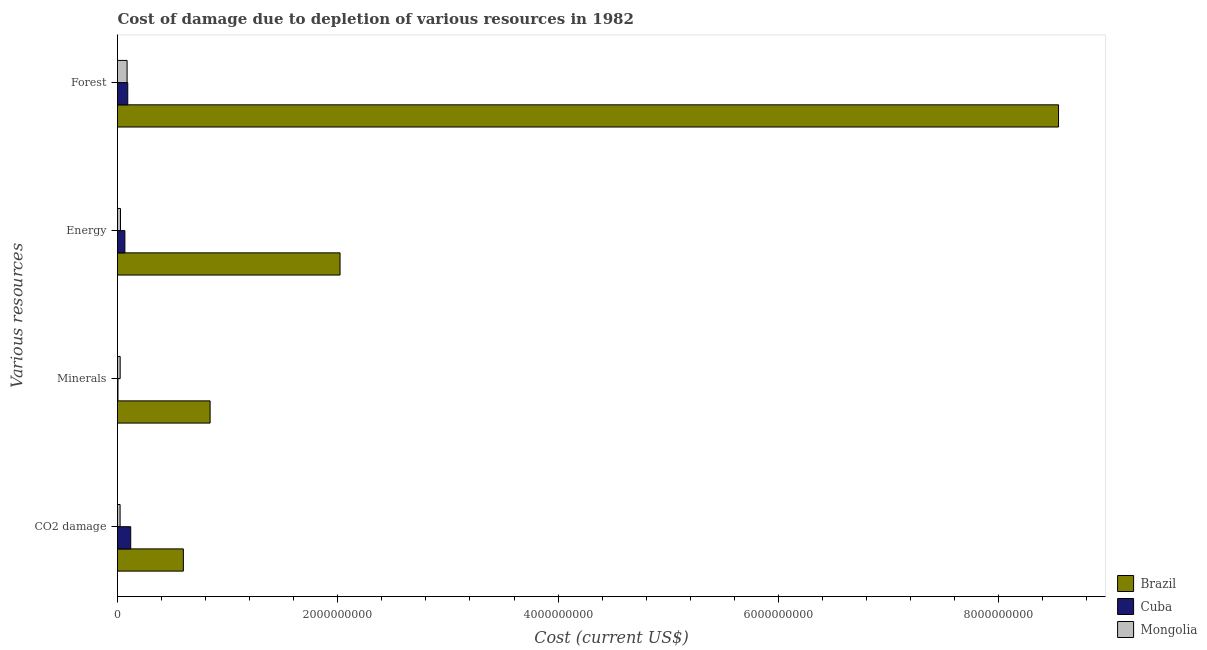How many bars are there on the 1st tick from the top?
Provide a short and direct response. 3. What is the label of the 3rd group of bars from the top?
Offer a very short reply. Minerals. What is the cost of damage due to depletion of energy in Cuba?
Provide a succinct answer. 6.70e+07. Across all countries, what is the maximum cost of damage due to depletion of coal?
Ensure brevity in your answer.  5.98e+08. Across all countries, what is the minimum cost of damage due to depletion of energy?
Your response must be concise. 2.71e+07. In which country was the cost of damage due to depletion of coal maximum?
Provide a short and direct response. Brazil. In which country was the cost of damage due to depletion of energy minimum?
Keep it short and to the point. Mongolia. What is the total cost of damage due to depletion of coal in the graph?
Keep it short and to the point. 7.41e+08. What is the difference between the cost of damage due to depletion of energy in Mongolia and that in Cuba?
Make the answer very short. -3.99e+07. What is the difference between the cost of damage due to depletion of coal in Mongolia and the cost of damage due to depletion of forests in Cuba?
Your response must be concise. -6.97e+07. What is the average cost of damage due to depletion of minerals per country?
Keep it short and to the point. 2.90e+08. What is the difference between the cost of damage due to depletion of minerals and cost of damage due to depletion of coal in Mongolia?
Your answer should be very brief. 7.37e+05. In how many countries, is the cost of damage due to depletion of forests greater than 8400000000 US$?
Ensure brevity in your answer.  1. What is the ratio of the cost of damage due to depletion of minerals in Mongolia to that in Brazil?
Your answer should be compact. 0.03. Is the cost of damage due to depletion of coal in Cuba less than that in Brazil?
Ensure brevity in your answer.  Yes. Is the difference between the cost of damage due to depletion of energy in Mongolia and Cuba greater than the difference between the cost of damage due to depletion of minerals in Mongolia and Cuba?
Ensure brevity in your answer.  No. What is the difference between the highest and the second highest cost of damage due to depletion of forests?
Your response must be concise. 8.45e+09. What is the difference between the highest and the lowest cost of damage due to depletion of energy?
Your answer should be very brief. 1.99e+09. Is the sum of the cost of damage due to depletion of coal in Mongolia and Brazil greater than the maximum cost of damage due to depletion of energy across all countries?
Your response must be concise. No. Is it the case that in every country, the sum of the cost of damage due to depletion of coal and cost of damage due to depletion of minerals is greater than the sum of cost of damage due to depletion of energy and cost of damage due to depletion of forests?
Keep it short and to the point. Yes. What does the 2nd bar from the top in CO2 damage represents?
Ensure brevity in your answer.  Cuba. Is it the case that in every country, the sum of the cost of damage due to depletion of coal and cost of damage due to depletion of minerals is greater than the cost of damage due to depletion of energy?
Your answer should be very brief. No. How many bars are there?
Ensure brevity in your answer.  12. How many countries are there in the graph?
Your answer should be compact. 3. What is the difference between two consecutive major ticks on the X-axis?
Make the answer very short. 2.00e+09. How are the legend labels stacked?
Provide a short and direct response. Vertical. What is the title of the graph?
Your answer should be compact. Cost of damage due to depletion of various resources in 1982 . Does "Belgium" appear as one of the legend labels in the graph?
Make the answer very short. No. What is the label or title of the X-axis?
Make the answer very short. Cost (current US$). What is the label or title of the Y-axis?
Your answer should be very brief. Various resources. What is the Cost (current US$) in Brazil in CO2 damage?
Ensure brevity in your answer.  5.98e+08. What is the Cost (current US$) of Cuba in CO2 damage?
Ensure brevity in your answer.  1.20e+08. What is the Cost (current US$) in Mongolia in CO2 damage?
Provide a succinct answer. 2.35e+07. What is the Cost (current US$) of Brazil in Minerals?
Provide a succinct answer. 8.41e+08. What is the Cost (current US$) of Cuba in Minerals?
Ensure brevity in your answer.  4.38e+06. What is the Cost (current US$) in Mongolia in Minerals?
Your answer should be compact. 2.42e+07. What is the Cost (current US$) of Brazil in Energy?
Offer a very short reply. 2.02e+09. What is the Cost (current US$) of Cuba in Energy?
Your answer should be very brief. 6.70e+07. What is the Cost (current US$) of Mongolia in Energy?
Make the answer very short. 2.71e+07. What is the Cost (current US$) in Brazil in Forest?
Make the answer very short. 8.54e+09. What is the Cost (current US$) of Cuba in Forest?
Your response must be concise. 9.31e+07. What is the Cost (current US$) in Mongolia in Forest?
Your response must be concise. 8.71e+07. Across all Various resources, what is the maximum Cost (current US$) in Brazil?
Make the answer very short. 8.54e+09. Across all Various resources, what is the maximum Cost (current US$) in Cuba?
Give a very brief answer. 1.20e+08. Across all Various resources, what is the maximum Cost (current US$) of Mongolia?
Your answer should be very brief. 8.71e+07. Across all Various resources, what is the minimum Cost (current US$) in Brazil?
Provide a short and direct response. 5.98e+08. Across all Various resources, what is the minimum Cost (current US$) in Cuba?
Make the answer very short. 4.38e+06. Across all Various resources, what is the minimum Cost (current US$) in Mongolia?
Your answer should be compact. 2.35e+07. What is the total Cost (current US$) in Brazil in the graph?
Your response must be concise. 1.20e+1. What is the total Cost (current US$) of Cuba in the graph?
Your answer should be very brief. 2.85e+08. What is the total Cost (current US$) in Mongolia in the graph?
Your answer should be compact. 1.62e+08. What is the difference between the Cost (current US$) in Brazil in CO2 damage and that in Minerals?
Make the answer very short. -2.43e+08. What is the difference between the Cost (current US$) of Cuba in CO2 damage and that in Minerals?
Your response must be concise. 1.16e+08. What is the difference between the Cost (current US$) in Mongolia in CO2 damage and that in Minerals?
Provide a succinct answer. -7.37e+05. What is the difference between the Cost (current US$) of Brazil in CO2 damage and that in Energy?
Your response must be concise. -1.42e+09. What is the difference between the Cost (current US$) in Cuba in CO2 damage and that in Energy?
Provide a succinct answer. 5.30e+07. What is the difference between the Cost (current US$) of Mongolia in CO2 damage and that in Energy?
Your answer should be very brief. -3.61e+06. What is the difference between the Cost (current US$) of Brazil in CO2 damage and that in Forest?
Your answer should be very brief. -7.95e+09. What is the difference between the Cost (current US$) of Cuba in CO2 damage and that in Forest?
Your answer should be compact. 2.69e+07. What is the difference between the Cost (current US$) of Mongolia in CO2 damage and that in Forest?
Your answer should be very brief. -6.36e+07. What is the difference between the Cost (current US$) of Brazil in Minerals and that in Energy?
Your answer should be compact. -1.18e+09. What is the difference between the Cost (current US$) in Cuba in Minerals and that in Energy?
Offer a terse response. -6.26e+07. What is the difference between the Cost (current US$) in Mongolia in Minerals and that in Energy?
Offer a very short reply. -2.87e+06. What is the difference between the Cost (current US$) of Brazil in Minerals and that in Forest?
Your answer should be compact. -7.70e+09. What is the difference between the Cost (current US$) of Cuba in Minerals and that in Forest?
Offer a terse response. -8.88e+07. What is the difference between the Cost (current US$) of Mongolia in Minerals and that in Forest?
Your response must be concise. -6.29e+07. What is the difference between the Cost (current US$) of Brazil in Energy and that in Forest?
Keep it short and to the point. -6.52e+09. What is the difference between the Cost (current US$) in Cuba in Energy and that in Forest?
Your response must be concise. -2.62e+07. What is the difference between the Cost (current US$) of Mongolia in Energy and that in Forest?
Provide a short and direct response. -6.00e+07. What is the difference between the Cost (current US$) in Brazil in CO2 damage and the Cost (current US$) in Cuba in Minerals?
Make the answer very short. 5.94e+08. What is the difference between the Cost (current US$) of Brazil in CO2 damage and the Cost (current US$) of Mongolia in Minerals?
Offer a terse response. 5.74e+08. What is the difference between the Cost (current US$) of Cuba in CO2 damage and the Cost (current US$) of Mongolia in Minerals?
Offer a terse response. 9.58e+07. What is the difference between the Cost (current US$) of Brazil in CO2 damage and the Cost (current US$) of Cuba in Energy?
Your response must be concise. 5.31e+08. What is the difference between the Cost (current US$) in Brazil in CO2 damage and the Cost (current US$) in Mongolia in Energy?
Your response must be concise. 5.71e+08. What is the difference between the Cost (current US$) in Cuba in CO2 damage and the Cost (current US$) in Mongolia in Energy?
Your answer should be compact. 9.29e+07. What is the difference between the Cost (current US$) in Brazil in CO2 damage and the Cost (current US$) in Cuba in Forest?
Give a very brief answer. 5.05e+08. What is the difference between the Cost (current US$) in Brazil in CO2 damage and the Cost (current US$) in Mongolia in Forest?
Your response must be concise. 5.11e+08. What is the difference between the Cost (current US$) in Cuba in CO2 damage and the Cost (current US$) in Mongolia in Forest?
Your answer should be compact. 3.29e+07. What is the difference between the Cost (current US$) in Brazil in Minerals and the Cost (current US$) in Cuba in Energy?
Offer a very short reply. 7.74e+08. What is the difference between the Cost (current US$) in Brazil in Minerals and the Cost (current US$) in Mongolia in Energy?
Your response must be concise. 8.14e+08. What is the difference between the Cost (current US$) of Cuba in Minerals and the Cost (current US$) of Mongolia in Energy?
Provide a succinct answer. -2.27e+07. What is the difference between the Cost (current US$) of Brazil in Minerals and the Cost (current US$) of Cuba in Forest?
Your answer should be very brief. 7.48e+08. What is the difference between the Cost (current US$) in Brazil in Minerals and the Cost (current US$) in Mongolia in Forest?
Make the answer very short. 7.54e+08. What is the difference between the Cost (current US$) of Cuba in Minerals and the Cost (current US$) of Mongolia in Forest?
Make the answer very short. -8.27e+07. What is the difference between the Cost (current US$) of Brazil in Energy and the Cost (current US$) of Cuba in Forest?
Your answer should be compact. 1.93e+09. What is the difference between the Cost (current US$) of Brazil in Energy and the Cost (current US$) of Mongolia in Forest?
Give a very brief answer. 1.93e+09. What is the difference between the Cost (current US$) of Cuba in Energy and the Cost (current US$) of Mongolia in Forest?
Your answer should be compact. -2.01e+07. What is the average Cost (current US$) in Brazil per Various resources?
Provide a short and direct response. 3.00e+09. What is the average Cost (current US$) of Cuba per Various resources?
Your response must be concise. 7.11e+07. What is the average Cost (current US$) in Mongolia per Various resources?
Give a very brief answer. 4.05e+07. What is the difference between the Cost (current US$) in Brazil and Cost (current US$) in Cuba in CO2 damage?
Keep it short and to the point. 4.78e+08. What is the difference between the Cost (current US$) in Brazil and Cost (current US$) in Mongolia in CO2 damage?
Keep it short and to the point. 5.75e+08. What is the difference between the Cost (current US$) of Cuba and Cost (current US$) of Mongolia in CO2 damage?
Your answer should be very brief. 9.65e+07. What is the difference between the Cost (current US$) in Brazil and Cost (current US$) in Cuba in Minerals?
Offer a terse response. 8.36e+08. What is the difference between the Cost (current US$) of Brazil and Cost (current US$) of Mongolia in Minerals?
Offer a very short reply. 8.16e+08. What is the difference between the Cost (current US$) of Cuba and Cost (current US$) of Mongolia in Minerals?
Offer a very short reply. -1.98e+07. What is the difference between the Cost (current US$) in Brazil and Cost (current US$) in Cuba in Energy?
Ensure brevity in your answer.  1.95e+09. What is the difference between the Cost (current US$) in Brazil and Cost (current US$) in Mongolia in Energy?
Ensure brevity in your answer.  1.99e+09. What is the difference between the Cost (current US$) of Cuba and Cost (current US$) of Mongolia in Energy?
Keep it short and to the point. 3.99e+07. What is the difference between the Cost (current US$) of Brazil and Cost (current US$) of Cuba in Forest?
Your answer should be very brief. 8.45e+09. What is the difference between the Cost (current US$) of Brazil and Cost (current US$) of Mongolia in Forest?
Give a very brief answer. 8.46e+09. What is the difference between the Cost (current US$) of Cuba and Cost (current US$) of Mongolia in Forest?
Your answer should be compact. 6.03e+06. What is the ratio of the Cost (current US$) in Brazil in CO2 damage to that in Minerals?
Give a very brief answer. 0.71. What is the ratio of the Cost (current US$) in Cuba in CO2 damage to that in Minerals?
Offer a terse response. 27.4. What is the ratio of the Cost (current US$) in Mongolia in CO2 damage to that in Minerals?
Provide a short and direct response. 0.97. What is the ratio of the Cost (current US$) in Brazil in CO2 damage to that in Energy?
Ensure brevity in your answer.  0.3. What is the ratio of the Cost (current US$) of Cuba in CO2 damage to that in Energy?
Offer a very short reply. 1.79. What is the ratio of the Cost (current US$) of Mongolia in CO2 damage to that in Energy?
Your response must be concise. 0.87. What is the ratio of the Cost (current US$) of Brazil in CO2 damage to that in Forest?
Give a very brief answer. 0.07. What is the ratio of the Cost (current US$) in Cuba in CO2 damage to that in Forest?
Your answer should be very brief. 1.29. What is the ratio of the Cost (current US$) in Mongolia in CO2 damage to that in Forest?
Provide a succinct answer. 0.27. What is the ratio of the Cost (current US$) in Brazil in Minerals to that in Energy?
Give a very brief answer. 0.42. What is the ratio of the Cost (current US$) in Cuba in Minerals to that in Energy?
Your answer should be very brief. 0.07. What is the ratio of the Cost (current US$) in Mongolia in Minerals to that in Energy?
Provide a succinct answer. 0.89. What is the ratio of the Cost (current US$) in Brazil in Minerals to that in Forest?
Offer a very short reply. 0.1. What is the ratio of the Cost (current US$) in Cuba in Minerals to that in Forest?
Offer a very short reply. 0.05. What is the ratio of the Cost (current US$) in Mongolia in Minerals to that in Forest?
Provide a short and direct response. 0.28. What is the ratio of the Cost (current US$) of Brazil in Energy to that in Forest?
Ensure brevity in your answer.  0.24. What is the ratio of the Cost (current US$) in Cuba in Energy to that in Forest?
Offer a terse response. 0.72. What is the ratio of the Cost (current US$) in Mongolia in Energy to that in Forest?
Make the answer very short. 0.31. What is the difference between the highest and the second highest Cost (current US$) of Brazil?
Make the answer very short. 6.52e+09. What is the difference between the highest and the second highest Cost (current US$) of Cuba?
Offer a terse response. 2.69e+07. What is the difference between the highest and the second highest Cost (current US$) in Mongolia?
Keep it short and to the point. 6.00e+07. What is the difference between the highest and the lowest Cost (current US$) in Brazil?
Your response must be concise. 7.95e+09. What is the difference between the highest and the lowest Cost (current US$) in Cuba?
Your answer should be very brief. 1.16e+08. What is the difference between the highest and the lowest Cost (current US$) of Mongolia?
Offer a terse response. 6.36e+07. 